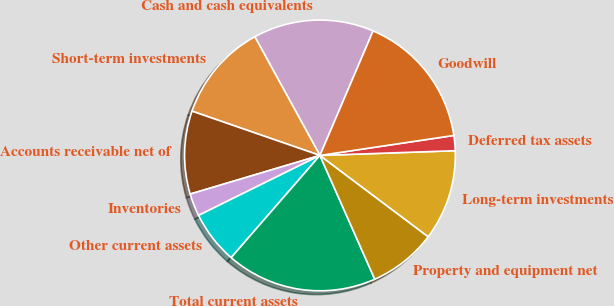Convert chart. <chart><loc_0><loc_0><loc_500><loc_500><pie_chart><fcel>Cash and cash equivalents<fcel>Short-term investments<fcel>Accounts receivable net of<fcel>Inventories<fcel>Other current assets<fcel>Total current assets<fcel>Property and equipment net<fcel>Long-term investments<fcel>Deferred tax assets<fcel>Goodwill<nl><fcel>14.41%<fcel>11.71%<fcel>9.91%<fcel>2.7%<fcel>6.31%<fcel>18.02%<fcel>8.11%<fcel>10.81%<fcel>1.8%<fcel>16.22%<nl></chart> 